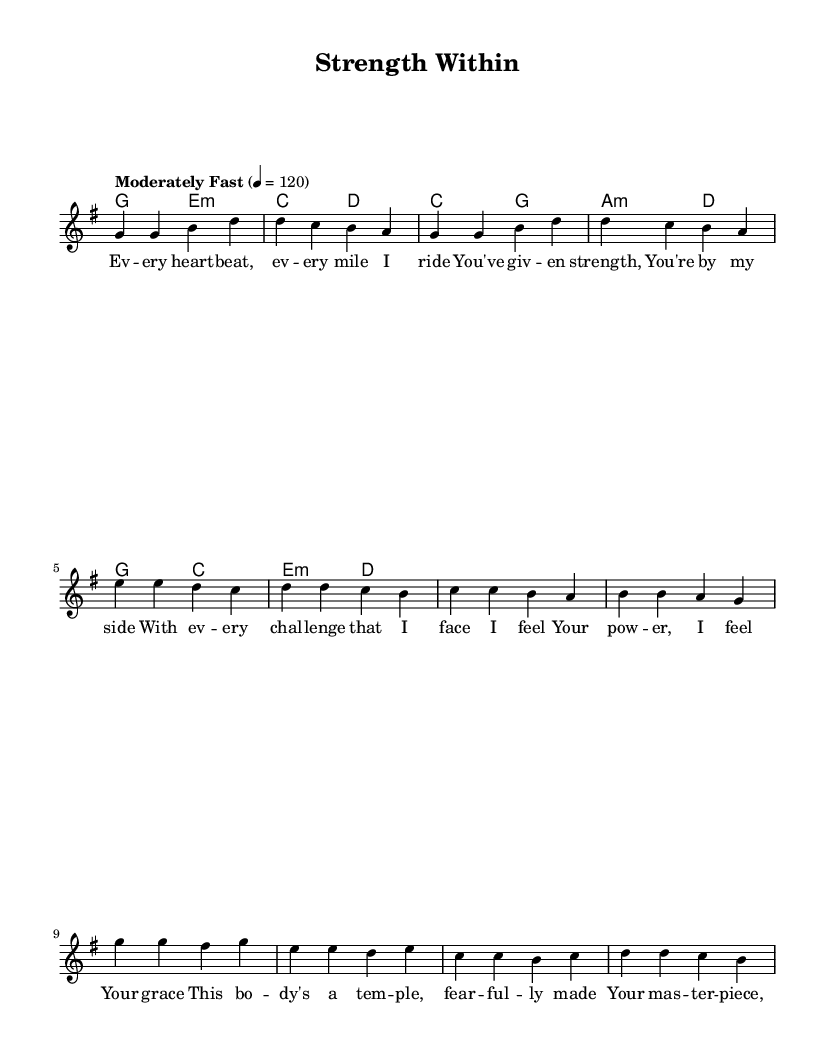What is the key signature of this music? The key signature is G major, which has one sharp (F#). You can identify this from the key signature indicated at the beginning of the score which shows a single sharp.
Answer: G major What is the time signature indicated in the piece? The time signature is 4/4, which means there are four beats per measure and the quarter note gets one beat. This is shown at the start of the score.
Answer: 4/4 What is the tempo marking for the music? The tempo marking is "Moderately Fast," with a metronome marking of 120 beats per minute. This can be located in the score, where the tempo is specified at the beginning.
Answer: Moderately Fast How many measures are in the verse? There are eight measures in the verse section based on the notation provided in the melody for the verse part. Each measure is separated by vertical lines in the sheet music.
Answer: 8 What type of harmony is used in the pre-chorus? The harmony used in the pre-chorus consists of triadic chords: C major and A minor, as shown in the chord mode for that section. You can see the chord symbols associated with the respective melody notes.
Answer: Triadic chords What is the main thematic focus of the lyrics? The main thematic focus of the lyrics revolves around strength and divine support, specifically celebrating the body as a temple. You can infer this from analyzing the message conveyed in the verses of the lyrics.
Answer: Strength and divine support What is the structure of the song? The structure of the song includes verses, a pre-chorus, and a chorus, which is typical for contemporary worship songs. This can be inferred from the labeled sections in the sheet music.
Answer: Verse, pre-chorus, chorus 